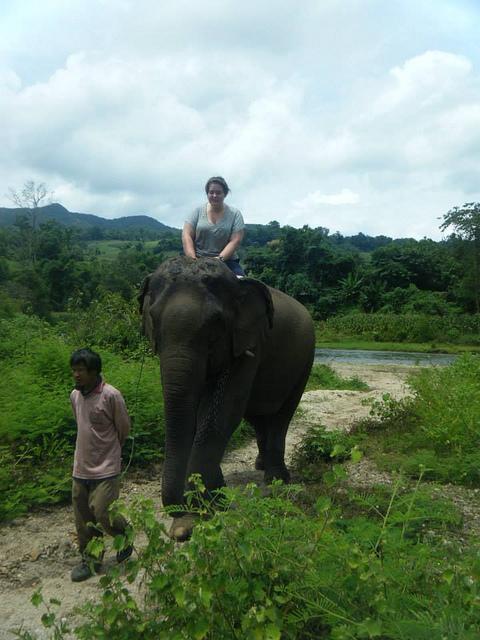Is the man standing?
Give a very brief answer. Yes. Does the elephant have a handler?
Quick response, please. Yes. Where are the elephants?
Give a very brief answer. Outside. Does the man's pants have stripes?
Be succinct. No. Where is the animal walking?
Quick response, please. Path. Is the elephant getting a bath?
Answer briefly. No. Is that a large elephant?
Be succinct. Yes. 